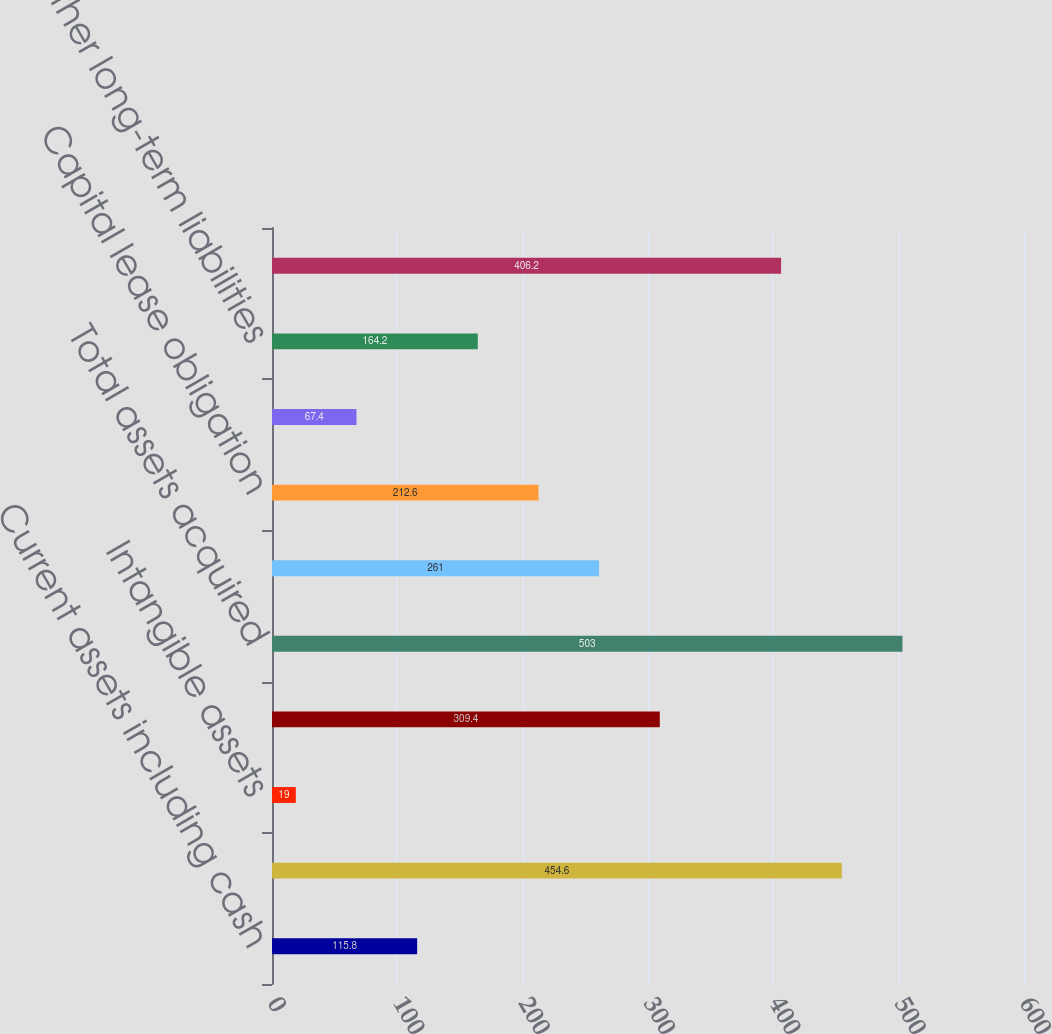Convert chart. <chart><loc_0><loc_0><loc_500><loc_500><bar_chart><fcel>Current assets including cash<fcel>Property plant and equipment<fcel>Intangible assets<fcel>Goodwill<fcel>Total assets acquired<fcel>Current liabilities other than<fcel>Capital lease obligation<fcel>Short-term borrowings<fcel>Other long-term liabilities<fcel>Total liabilities assumed<nl><fcel>115.8<fcel>454.6<fcel>19<fcel>309.4<fcel>503<fcel>261<fcel>212.6<fcel>67.4<fcel>164.2<fcel>406.2<nl></chart> 